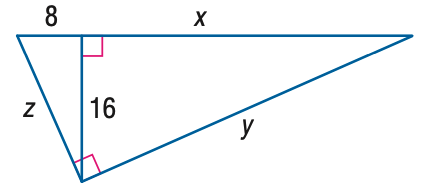Answer the mathemtical geometry problem and directly provide the correct option letter.
Question: Find x.
Choices: A: 8 B: 16 C: 32 D: 64 C 